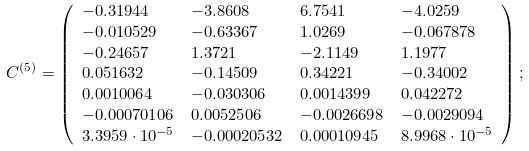<formula> <loc_0><loc_0><loc_500><loc_500>C ^ { ( 5 ) } & = \left ( \begin{array} { l l l l } - 0 . 3 1 9 4 4 & - 3 . 8 6 0 8 & 6 . 7 5 4 1 & - 4 . 0 2 5 9 \\ - 0 . 0 1 0 5 2 9 & - 0 . 6 3 3 6 7 & 1 . 0 2 6 9 & - 0 . 0 6 7 8 7 8 \\ - 0 . 2 4 6 5 7 & 1 . 3 7 2 1 & - 2 . 1 1 4 9 & 1 . 1 9 7 7 \\ 0 . 0 5 1 6 3 2 & - 0 . 1 4 5 0 9 & 0 . 3 4 2 2 1 & - 0 . 3 4 0 0 2 \\ 0 . 0 0 1 0 0 6 4 & - 0 . 0 3 0 3 0 6 & 0 . 0 0 1 4 3 9 9 & 0 . 0 4 2 2 7 2 \\ - 0 . 0 0 0 7 0 1 0 6 & 0 . 0 0 5 2 5 0 6 & - 0 . 0 0 2 6 6 9 8 & - 0 . 0 0 2 9 0 9 4 \\ 3 . 3 9 5 9 \cdot 1 0 ^ { - 5 } & - 0 . 0 0 0 2 0 5 3 2 & 0 . 0 0 0 1 0 9 4 5 & 8 . 9 9 6 8 \cdot 1 0 ^ { - 5 } \\ \end{array} \right ) ;</formula> 